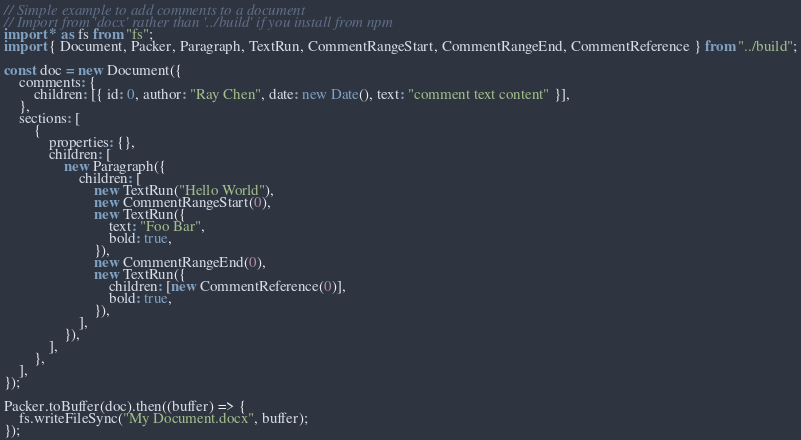Convert code to text. <code><loc_0><loc_0><loc_500><loc_500><_TypeScript_>// Simple example to add comments to a document
// Import from 'docx' rather than '../build' if you install from npm
import * as fs from "fs";
import { Document, Packer, Paragraph, TextRun, CommentRangeStart, CommentRangeEnd, CommentReference } from "../build";

const doc = new Document({
    comments: {
        children: [{ id: 0, author: "Ray Chen", date: new Date(), text: "comment text content" }],
    },
    sections: [
        {
            properties: {},
            children: [
                new Paragraph({
                    children: [
                        new TextRun("Hello World"),
                        new CommentRangeStart(0),
                        new TextRun({
                            text: "Foo Bar",
                            bold: true,
                        }),
                        new CommentRangeEnd(0),
                        new TextRun({
                            children: [new CommentReference(0)],
                            bold: true,
                        }),
                    ],
                }),
            ],
        },
    ],
});

Packer.toBuffer(doc).then((buffer) => {
    fs.writeFileSync("My Document.docx", buffer);
});
</code> 